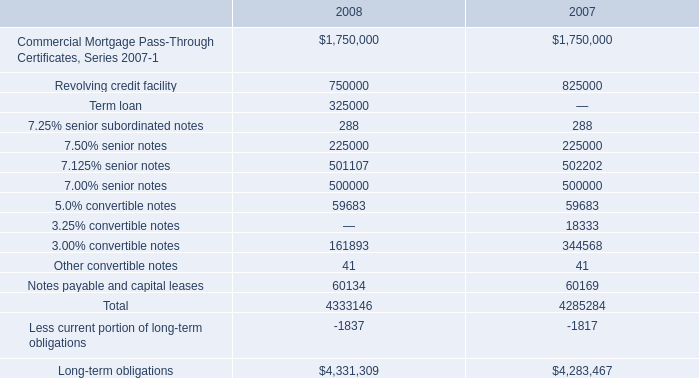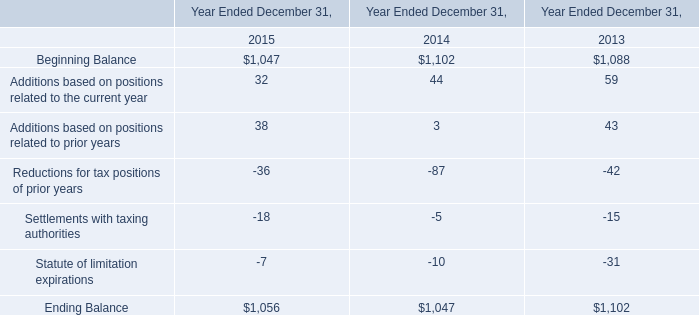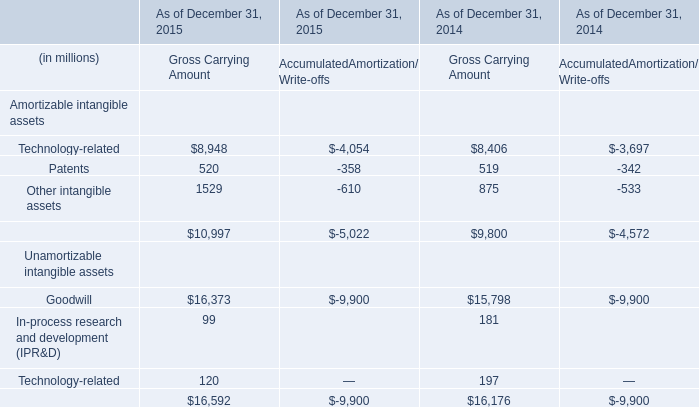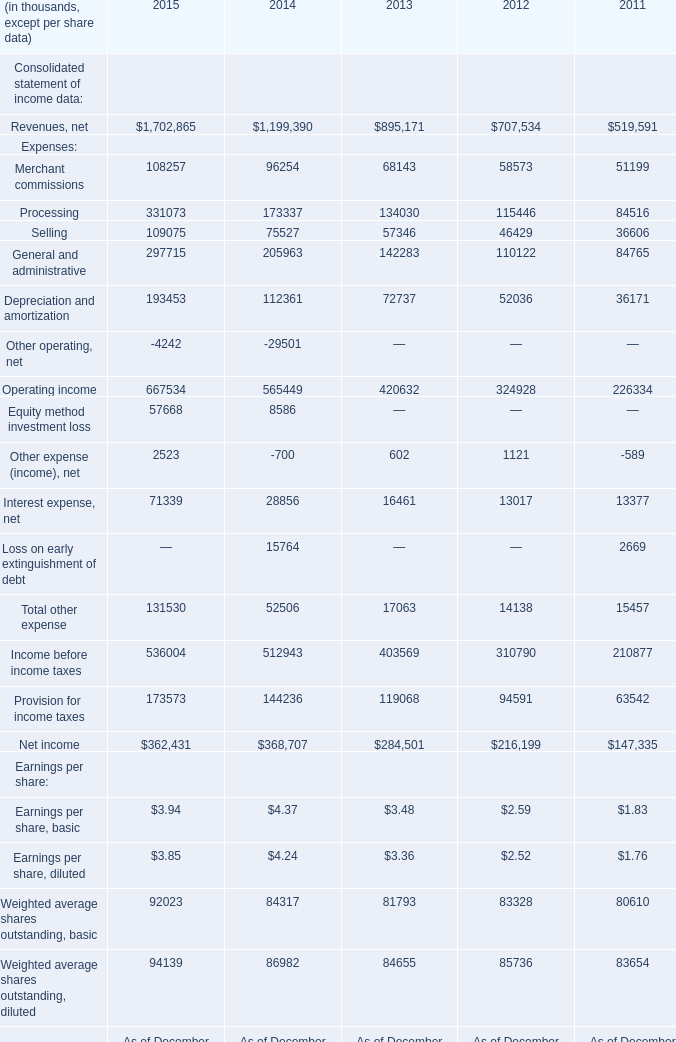What's the average of the Additions based on positions related to the current year in the years where Patents for Amortizable intangible assets for Gross Carrying Amount is positive? 
Computations: ((32 + 44) / 2)
Answer: 38.0. 